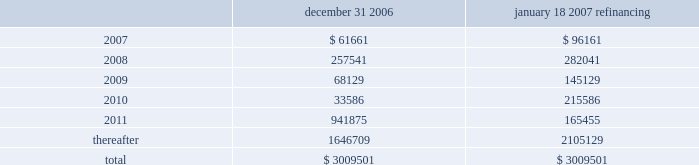Through the certegy merger , the company has an obligation to service $ 200 million ( aggregate principal amount ) of unsecured 4.75% ( 4.75 % ) fixed-rate notes due in 2008 .
The notes were recorded in purchase accounting at a discount of $ 5.7 million , which is being amortized over the term of the notes .
The notes accrue interest at a rate of 4.75% ( 4.75 % ) per year , payable semi-annually in arrears on each march 15 and september 15 .
On april 11 , 2005 , fis entered into interest rate swap agreements which have effectively fixed the interest rate at approximately 5.4% ( 5.4 % ) through april 2008 on $ 350 million of the term loan facilities ( or its replacement debt ) and at approximately 5.2% ( 5.2 % ) through april 2007 on an additional $ 350 million of the term loan .
The company has designated these interest rate swaps as cash flow hedges in accordance with sfas no .
133 .
The estimated fair value of the cash flow hedges results in an asset to the company of $ 4.9 million and $ 5.2 million , as of december 31 , 2006 and december 31 , 2005 , respectively , which is included in the accompanying consolidated balance sheets in other noncurrent assets and as a component of accumulated other comprehensive earnings , net of deferred taxes .
A portion of the amount included in accumulated other comprehensive earnings is reclassified into interest expense as a yield adjustment as interest payments are made on the term loan facilities .
The company 2019s existing cash flow hedges are highly effective and there is no current impact on earnings due to hedge ineffectiveness .
It is the policy of the company to execute such instruments with credit-worthy banks and not to enter into derivative financial instruments for speculative purposes .
Principal maturities at december 31 , 2006 ( and at december 31 , 2006 after giving effect to the debt refinancing completed on january 18 , 2007 ) for the next five years and thereafter are as follows ( in thousands ) : december 31 , january 18 , 2007 refinancing .
Fidelity national information services , inc .
And subsidiaries and affiliates consolidated and combined financial statements notes to consolidated and combined financial statements 2014 ( continued ) .
What is the yearly interest expense associated with the certegy merger , ( in millions ) ? 
Computations: (200 * 4.75%)
Answer: 9.5. Through the certegy merger , the company has an obligation to service $ 200 million ( aggregate principal amount ) of unsecured 4.75% ( 4.75 % ) fixed-rate notes due in 2008 .
The notes were recorded in purchase accounting at a discount of $ 5.7 million , which is being amortized over the term of the notes .
The notes accrue interest at a rate of 4.75% ( 4.75 % ) per year , payable semi-annually in arrears on each march 15 and september 15 .
On april 11 , 2005 , fis entered into interest rate swap agreements which have effectively fixed the interest rate at approximately 5.4% ( 5.4 % ) through april 2008 on $ 350 million of the term loan facilities ( or its replacement debt ) and at approximately 5.2% ( 5.2 % ) through april 2007 on an additional $ 350 million of the term loan .
The company has designated these interest rate swaps as cash flow hedges in accordance with sfas no .
133 .
The estimated fair value of the cash flow hedges results in an asset to the company of $ 4.9 million and $ 5.2 million , as of december 31 , 2006 and december 31 , 2005 , respectively , which is included in the accompanying consolidated balance sheets in other noncurrent assets and as a component of accumulated other comprehensive earnings , net of deferred taxes .
A portion of the amount included in accumulated other comprehensive earnings is reclassified into interest expense as a yield adjustment as interest payments are made on the term loan facilities .
The company 2019s existing cash flow hedges are highly effective and there is no current impact on earnings due to hedge ineffectiveness .
It is the policy of the company to execute such instruments with credit-worthy banks and not to enter into derivative financial instruments for speculative purposes .
Principal maturities at december 31 , 2006 ( and at december 31 , 2006 after giving effect to the debt refinancing completed on january 18 , 2007 ) for the next five years and thereafter are as follows ( in thousands ) : december 31 , january 18 , 2007 refinancing .
Fidelity national information services , inc .
And subsidiaries and affiliates consolidated and combined financial statements notes to consolidated and combined financial statements 2014 ( continued ) .
What was the change , in thousands , of principal maturities due in 2008 after the the debt refinancing completed on january 18 , 2007? 
Computations: (257541 - 282041)
Answer: -24500.0. 